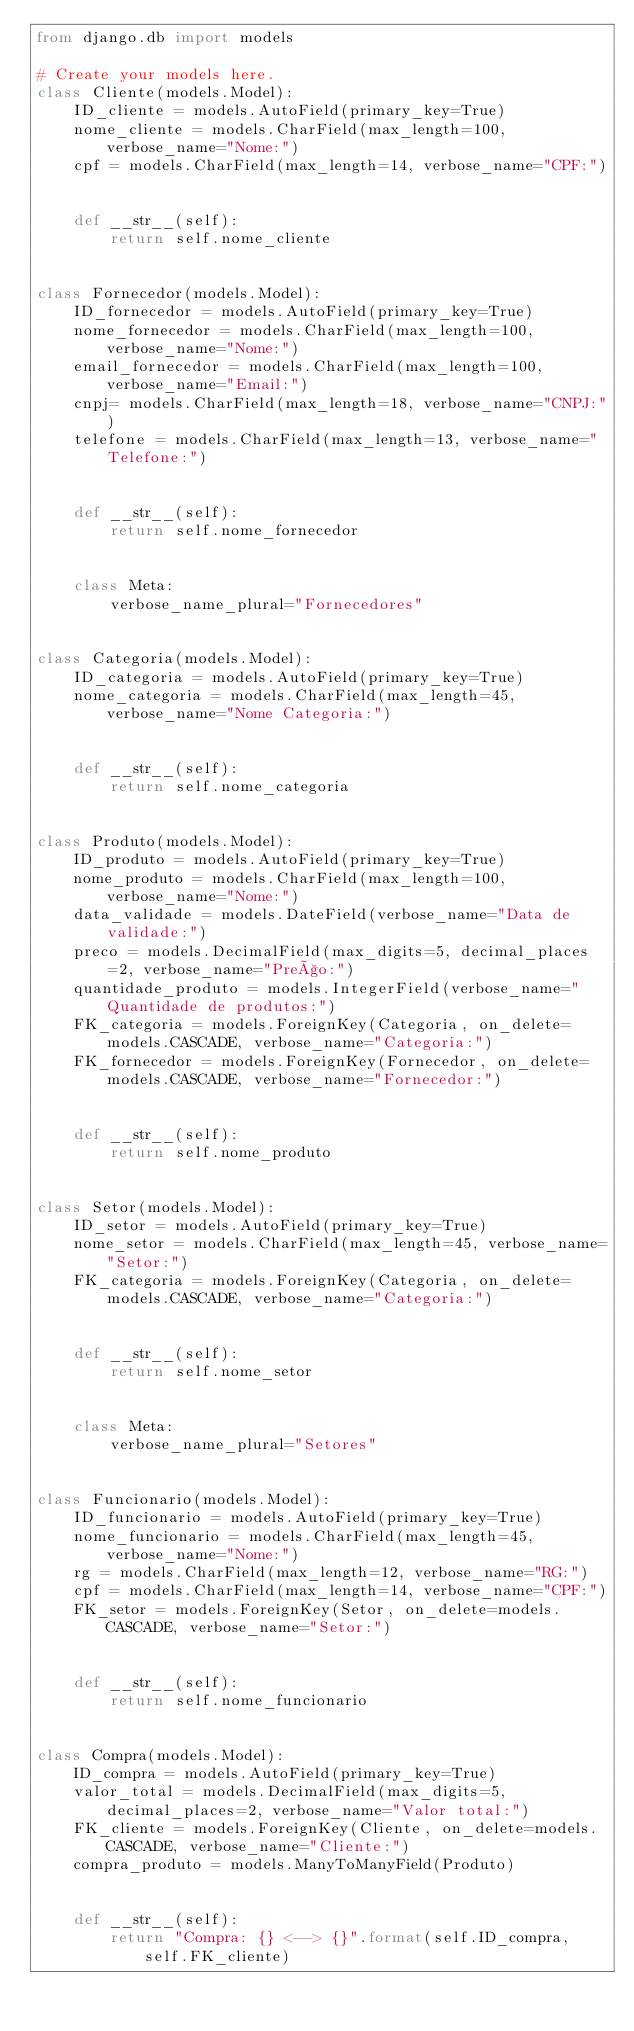<code> <loc_0><loc_0><loc_500><loc_500><_Python_>from django.db import models

# Create your models here.
class Cliente(models.Model):
    ID_cliente = models.AutoField(primary_key=True)
    nome_cliente = models.CharField(max_length=100, verbose_name="Nome:")
    cpf = models.CharField(max_length=14, verbose_name="CPF:")


    def __str__(self):
        return self.nome_cliente


class Fornecedor(models.Model):
    ID_fornecedor = models.AutoField(primary_key=True)
    nome_fornecedor = models.CharField(max_length=100, verbose_name="Nome:")
    email_fornecedor = models.CharField(max_length=100, verbose_name="Email:")
    cnpj= models.CharField(max_length=18, verbose_name="CNPJ:")
    telefone = models.CharField(max_length=13, verbose_name="Telefone:")


    def __str__(self):
        return self.nome_fornecedor


    class Meta:
        verbose_name_plural="Fornecedores"


class Categoria(models.Model):
    ID_categoria = models.AutoField(primary_key=True)
    nome_categoria = models.CharField(max_length=45, verbose_name="Nome Categoria:")


    def __str__(self):
        return self.nome_categoria


class Produto(models.Model):
    ID_produto = models.AutoField(primary_key=True)
    nome_produto = models.CharField(max_length=100, verbose_name="Nome:")
    data_validade = models.DateField(verbose_name="Data de validade:")
    preco = models.DecimalField(max_digits=5, decimal_places=2, verbose_name="Preço:")
    quantidade_produto = models.IntegerField(verbose_name="Quantidade de produtos:")
    FK_categoria = models.ForeignKey(Categoria, on_delete=models.CASCADE, verbose_name="Categoria:")
    FK_fornecedor = models.ForeignKey(Fornecedor, on_delete=models.CASCADE, verbose_name="Fornecedor:")


    def __str__(self):
        return self.nome_produto
    

class Setor(models.Model):
    ID_setor = models.AutoField(primary_key=True)
    nome_setor = models.CharField(max_length=45, verbose_name="Setor:")
    FK_categoria = models.ForeignKey(Categoria, on_delete=models.CASCADE, verbose_name="Categoria:")


    def __str__(self):
        return self.nome_setor


    class Meta:
        verbose_name_plural="Setores"


class Funcionario(models.Model):
    ID_funcionario = models.AutoField(primary_key=True)
    nome_funcionario = models.CharField(max_length=45, verbose_name="Nome:")
    rg = models.CharField(max_length=12, verbose_name="RG:")
    cpf = models.CharField(max_length=14, verbose_name="CPF:")
    FK_setor = models.ForeignKey(Setor, on_delete=models.CASCADE, verbose_name="Setor:")


    def __str__(self):
        return self.nome_funcionario


class Compra(models.Model):
    ID_compra = models.AutoField(primary_key=True)
    valor_total = models.DecimalField(max_digits=5, decimal_places=2, verbose_name="Valor total:")
    FK_cliente = models.ForeignKey(Cliente, on_delete=models.CASCADE, verbose_name="Cliente:")
    compra_produto = models.ManyToManyField(Produto)


    def __str__(self):
        return "Compra: {} <--> {}".format(self.ID_compra, self.FK_cliente)
   </code> 